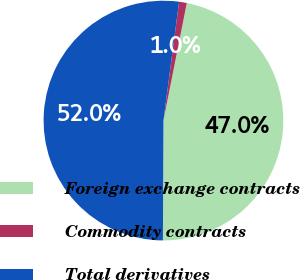<chart> <loc_0><loc_0><loc_500><loc_500><pie_chart><fcel>Foreign exchange contracts<fcel>Commodity contracts<fcel>Total derivatives<nl><fcel>46.95%<fcel>1.04%<fcel>52.0%<nl></chart> 